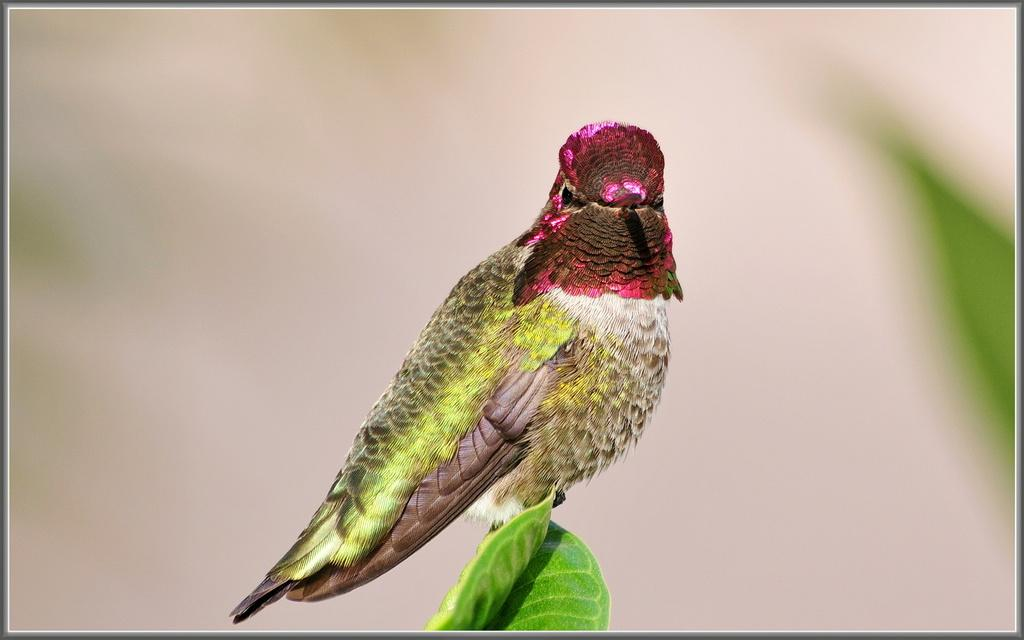What type of animal can be seen in the image? There is a bird in the image. Where is the bird located? The bird is on a leaf. What colors can be observed on the bird? The bird has pink, green, and brown colors. Is there a humorous scene involving a cave and a fight in the image? No, there is no cave, fight, or humor present in the image; it features a bird on a leaf with pink, green, and brown colors. 